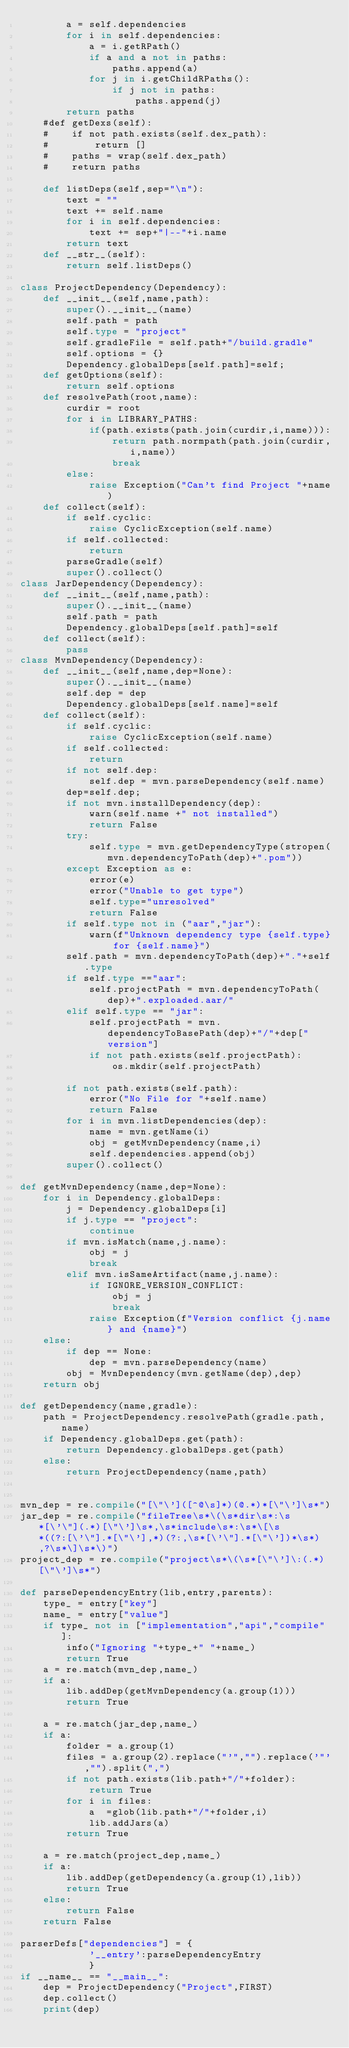Convert code to text. <code><loc_0><loc_0><loc_500><loc_500><_Python_>        a = self.dependencies
        for i in self.dependencies:
            a = i.getRPath()
            if a and a not in paths:
                paths.append(a)
            for j in i.getChildRPaths():
                if j not in paths:
                    paths.append(j)
        return paths
    #def getDexs(self):
    #    if not path.exists(self.dex_path):
    #        return []
    #    paths = wrap(self.dex_path)
    #    return paths

    def listDeps(self,sep="\n"):
        text = ""
        text += self.name
        for i in self.dependencies:
            text += sep+"|--"+i.name
        return text
    def __str__(self):
        return self.listDeps()
  
class ProjectDependency(Dependency):
    def __init__(self,name,path):
        super().__init__(name)
        self.path = path
        self.type = "project"
        self.gradleFile = self.path+"/build.gradle"
        self.options = {}
        Dependency.globalDeps[self.path]=self;
    def getOptions(self):
        return self.options
    def resolvePath(root,name):
        curdir = root
        for i in LIBRARY_PATHS:
            if(path.exists(path.join(curdir,i,name))):
                return path.normpath(path.join(curdir,i,name))
                break
        else:
            raise Exception("Can't find Project "+name)
    def collect(self):
        if self.cyclic:
            raise CyclicException(self.name)
        if self.collected:
            return
        parseGradle(self)
        super().collect()
class JarDependency(Dependency):
    def __init__(self,name,path):
        super().__init__(name)
        self.path = path
        Dependency.globalDeps[self.path]=self
    def collect(self):
        pass
class MvnDependency(Dependency):
    def __init__(self,name,dep=None):
        super().__init__(name)
        self.dep = dep
        Dependency.globalDeps[self.name]=self
    def collect(self):
        if self.cyclic:
            raise CyclicException(self.name)
        if self.collected:
            return
        if not self.dep:
            self.dep = mvn.parseDependency(self.name)
        dep=self.dep;
        if not mvn.installDependency(dep):
            warn(self.name +" not installed")
            return False
        try:
            self.type = mvn.getDependencyType(stropen(mvn.dependencyToPath(dep)+".pom"))
        except Exception as e:
            error(e)
            error("Unable to get type")
            self.type="unresolved"
            return False
        if self.type not in ("aar","jar"):
            warn(f"Unknown dependency type {self.type} for {self.name}")
        self.path = mvn.dependencyToPath(dep)+"."+self.type
        if self.type =="aar":
            self.projectPath = mvn.dependencyToPath(dep)+".exploaded.aar/"
        elif self.type == "jar":
            self.projectPath = mvn.dependencyToBasePath(dep)+"/"+dep["version"]
            if not path.exists(self.projectPath):
                os.mkdir(self.projectPath)
            
        if not path.exists(self.path):
            error("No File for "+self.name)
            return False
        for i in mvn.listDependencies(dep):
            name = mvn.getName(i)
            obj = getMvnDependency(name,i)
            self.dependencies.append(obj)
        super().collect()
        
def getMvnDependency(name,dep=None):
    for i in Dependency.globalDeps:
        j = Dependency.globalDeps[i]
        if j.type == "project":
            continue
        if mvn.isMatch(name,j.name):
            obj = j
            break
        elif mvn.isSameArtifact(name,j.name):
            if IGNORE_VERSION_CONFLICT:
                obj = j
                break
            raise Exception(f"Version conflict {j.name} and {name}")
    else:
        if dep == None:
            dep = mvn.parseDependency(name)
        obj = MvnDependency(mvn.getName(dep),dep)
    return obj

def getDependency(name,gradle):
    path = ProjectDependency.resolvePath(gradle.path,name)
    if Dependency.globalDeps.get(path):
        return Dependency.globalDeps.get(path)
    else:
        return ProjectDependency(name,path)


mvn_dep = re.compile("[\"\']([^@\s]*)(@.*)*[\"\']\s*")
jar_dep = re.compile("fileTree\s*\(\s*dir\s*:\s*[\'\"](.*)[\"\']\s*,\s*include\s*:\s*\[\s*((?:[\'\"].*[\"\'],*)(?:,\s*[\'\"].*[\"\'])*\s*),?\s*\]\s*\)")
project_dep = re.compile("project\s*\(\s*[\"\']\:(.*)[\"\']\s*")

def parseDependencyEntry(lib,entry,parents):
    type_ = entry["key"]
    name_ = entry["value"]
    if type_ not in ["implementation","api","compile"]:
        info("Ignoring "+type_+" "+name_)
        return True
    a = re.match(mvn_dep,name_)
    if a:
        lib.addDep(getMvnDependency(a.group(1)))
        return True
    
    a = re.match(jar_dep,name_)
    if a:
        folder = a.group(1)
        files = a.group(2).replace("'","").replace('"',"").split(",")
        if not path.exists(lib.path+"/"+folder):
            return True
        for i in files:
            a  =glob(lib.path+"/"+folder,i)
            lib.addJars(a)
        return True

    a = re.match(project_dep,name_)
    if a:
        lib.addDep(getDependency(a.group(1),lib))
        return True
    else:
        return False
    return False

parserDefs["dependencies"] = {
            '__entry':parseDependencyEntry
            }
if __name__ == "__main__":
    dep = ProjectDependency("Project",FIRST) 
    dep.collect()
    print(dep)
</code> 